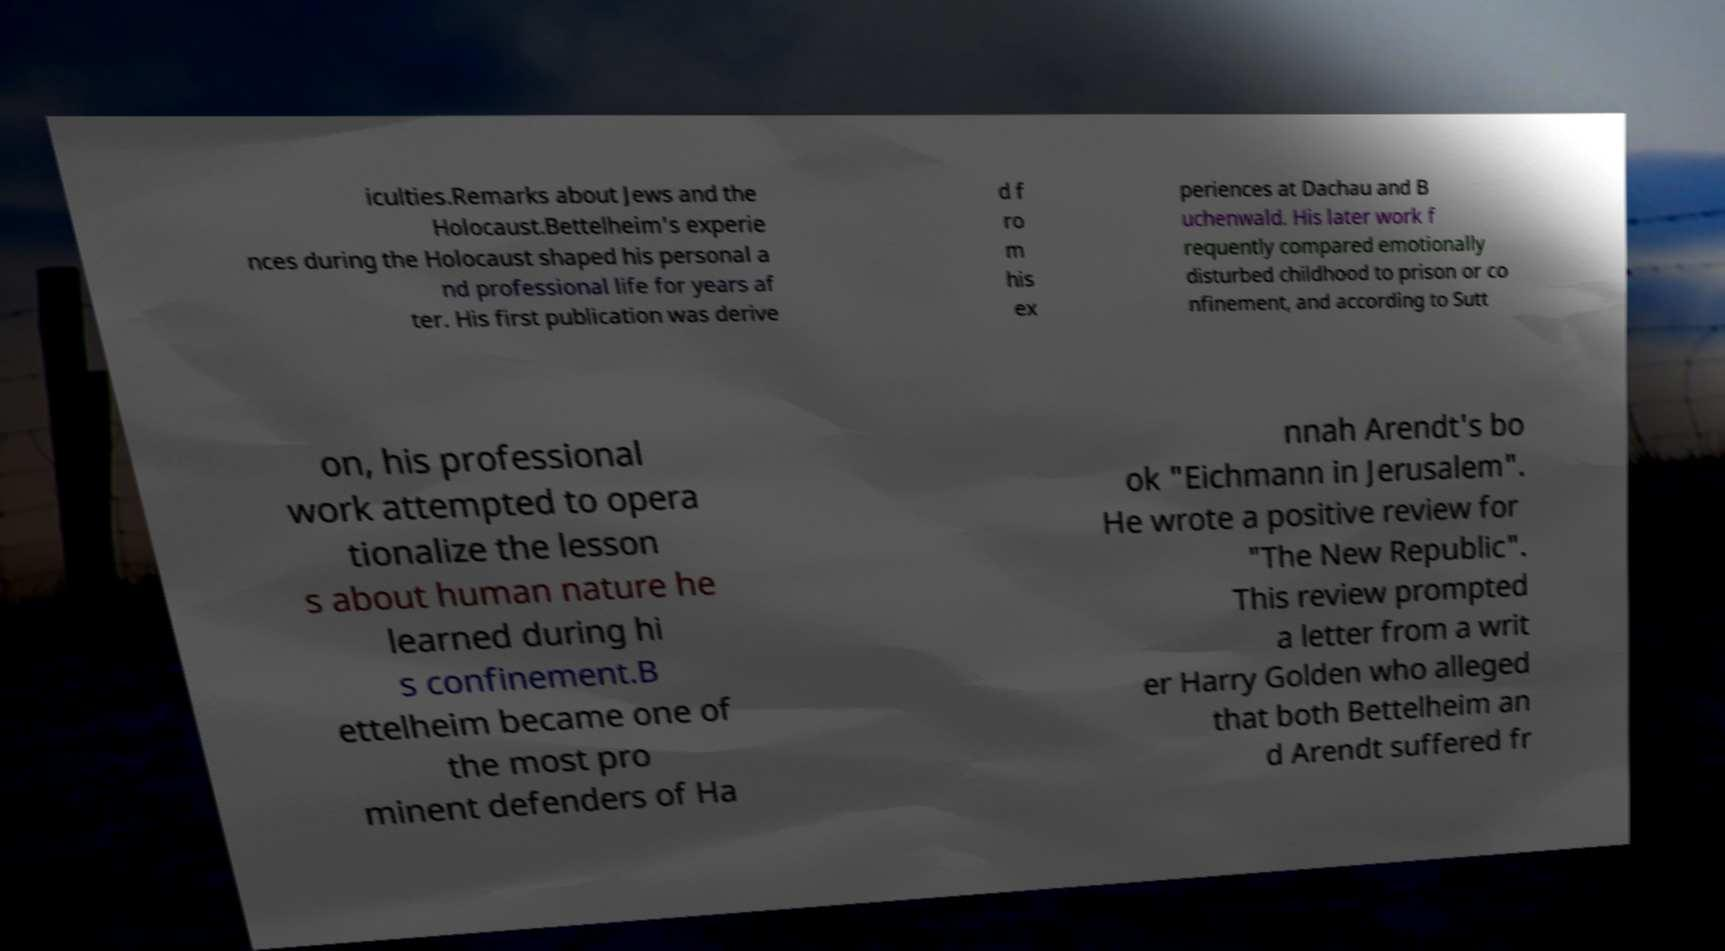Could you assist in decoding the text presented in this image and type it out clearly? iculties.Remarks about Jews and the Holocaust.Bettelheim's experie nces during the Holocaust shaped his personal a nd professional life for years af ter. His first publication was derive d f ro m his ex periences at Dachau and B uchenwald. His later work f requently compared emotionally disturbed childhood to prison or co nfinement, and according to Sutt on, his professional work attempted to opera tionalize the lesson s about human nature he learned during hi s confinement.B ettelheim became one of the most pro minent defenders of Ha nnah Arendt's bo ok "Eichmann in Jerusalem". He wrote a positive review for "The New Republic". This review prompted a letter from a writ er Harry Golden who alleged that both Bettelheim an d Arendt suffered fr 